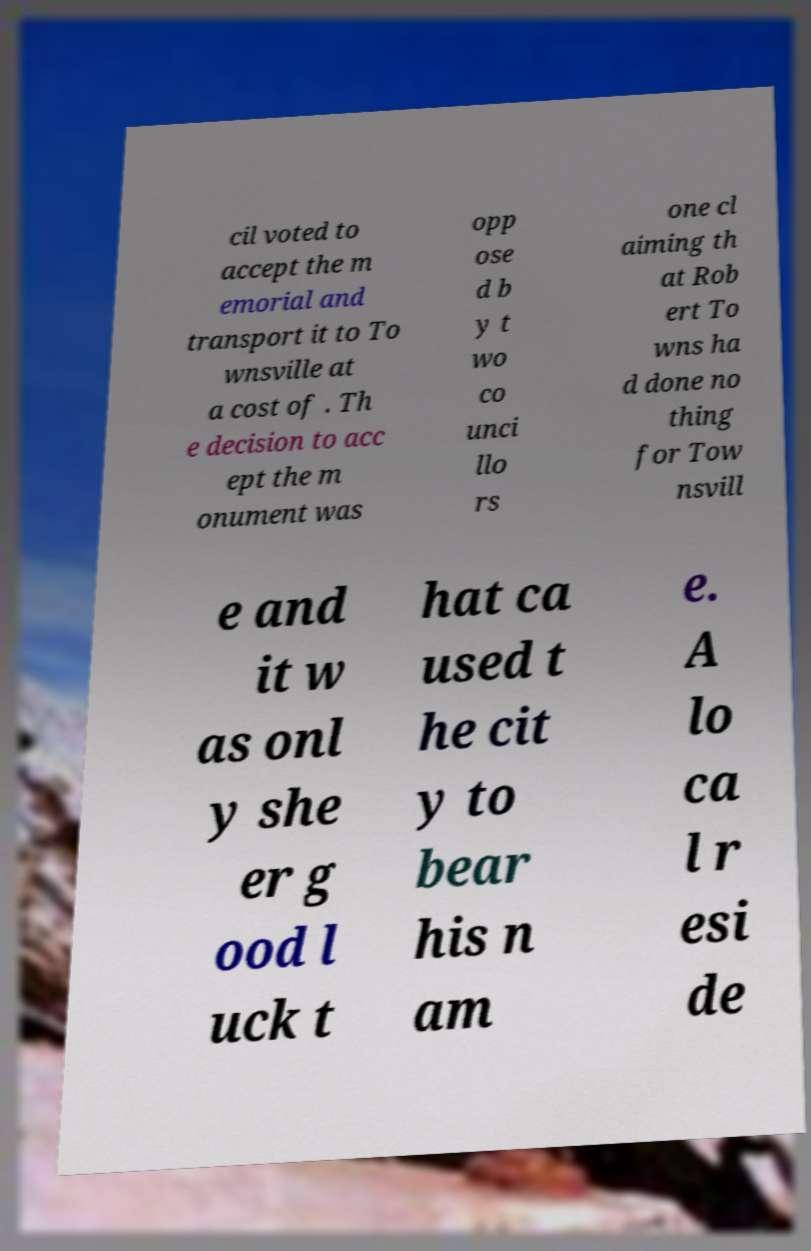For documentation purposes, I need the text within this image transcribed. Could you provide that? cil voted to accept the m emorial and transport it to To wnsville at a cost of . Th e decision to acc ept the m onument was opp ose d b y t wo co unci llo rs one cl aiming th at Rob ert To wns ha d done no thing for Tow nsvill e and it w as onl y she er g ood l uck t hat ca used t he cit y to bear his n am e. A lo ca l r esi de 